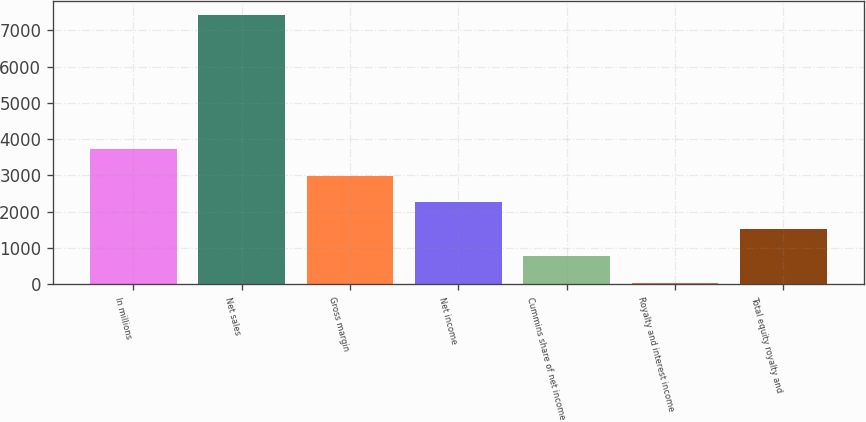Convert chart. <chart><loc_0><loc_0><loc_500><loc_500><bar_chart><fcel>In millions<fcel>Net sales<fcel>Gross margin<fcel>Net income<fcel>Cummins share of net income<fcel>Royalty and interest income<fcel>Total equity royalty and<nl><fcel>3733<fcel>7426<fcel>2994.4<fcel>2255.8<fcel>778.6<fcel>40<fcel>1517.2<nl></chart> 